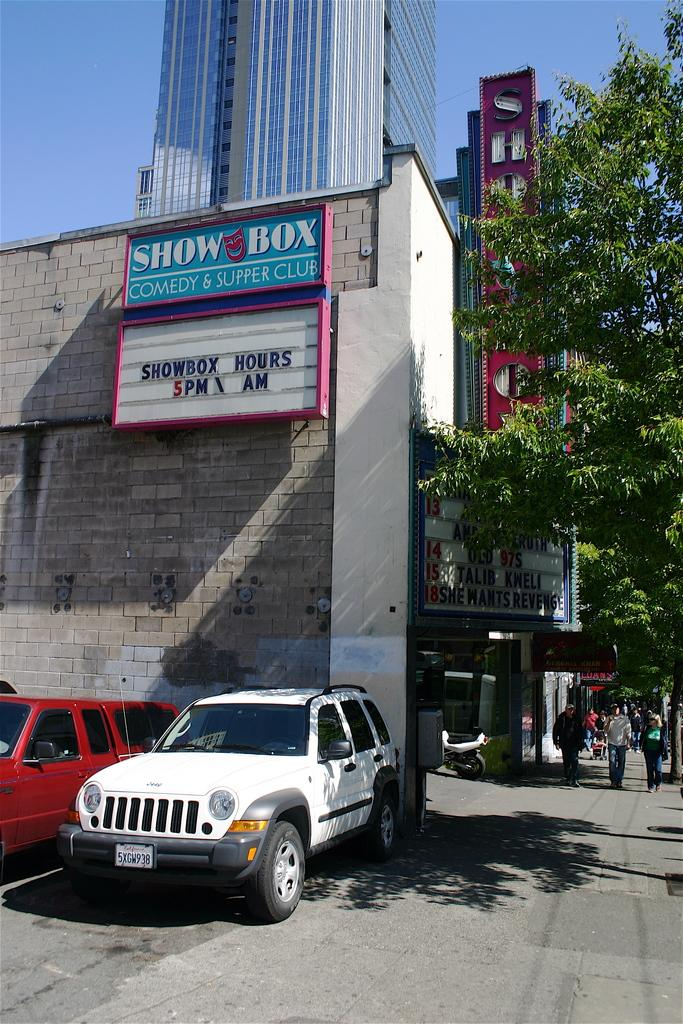<image>
Summarize the visual content of the image. A letter board sign says that the Showbox opens at 5 pm. 